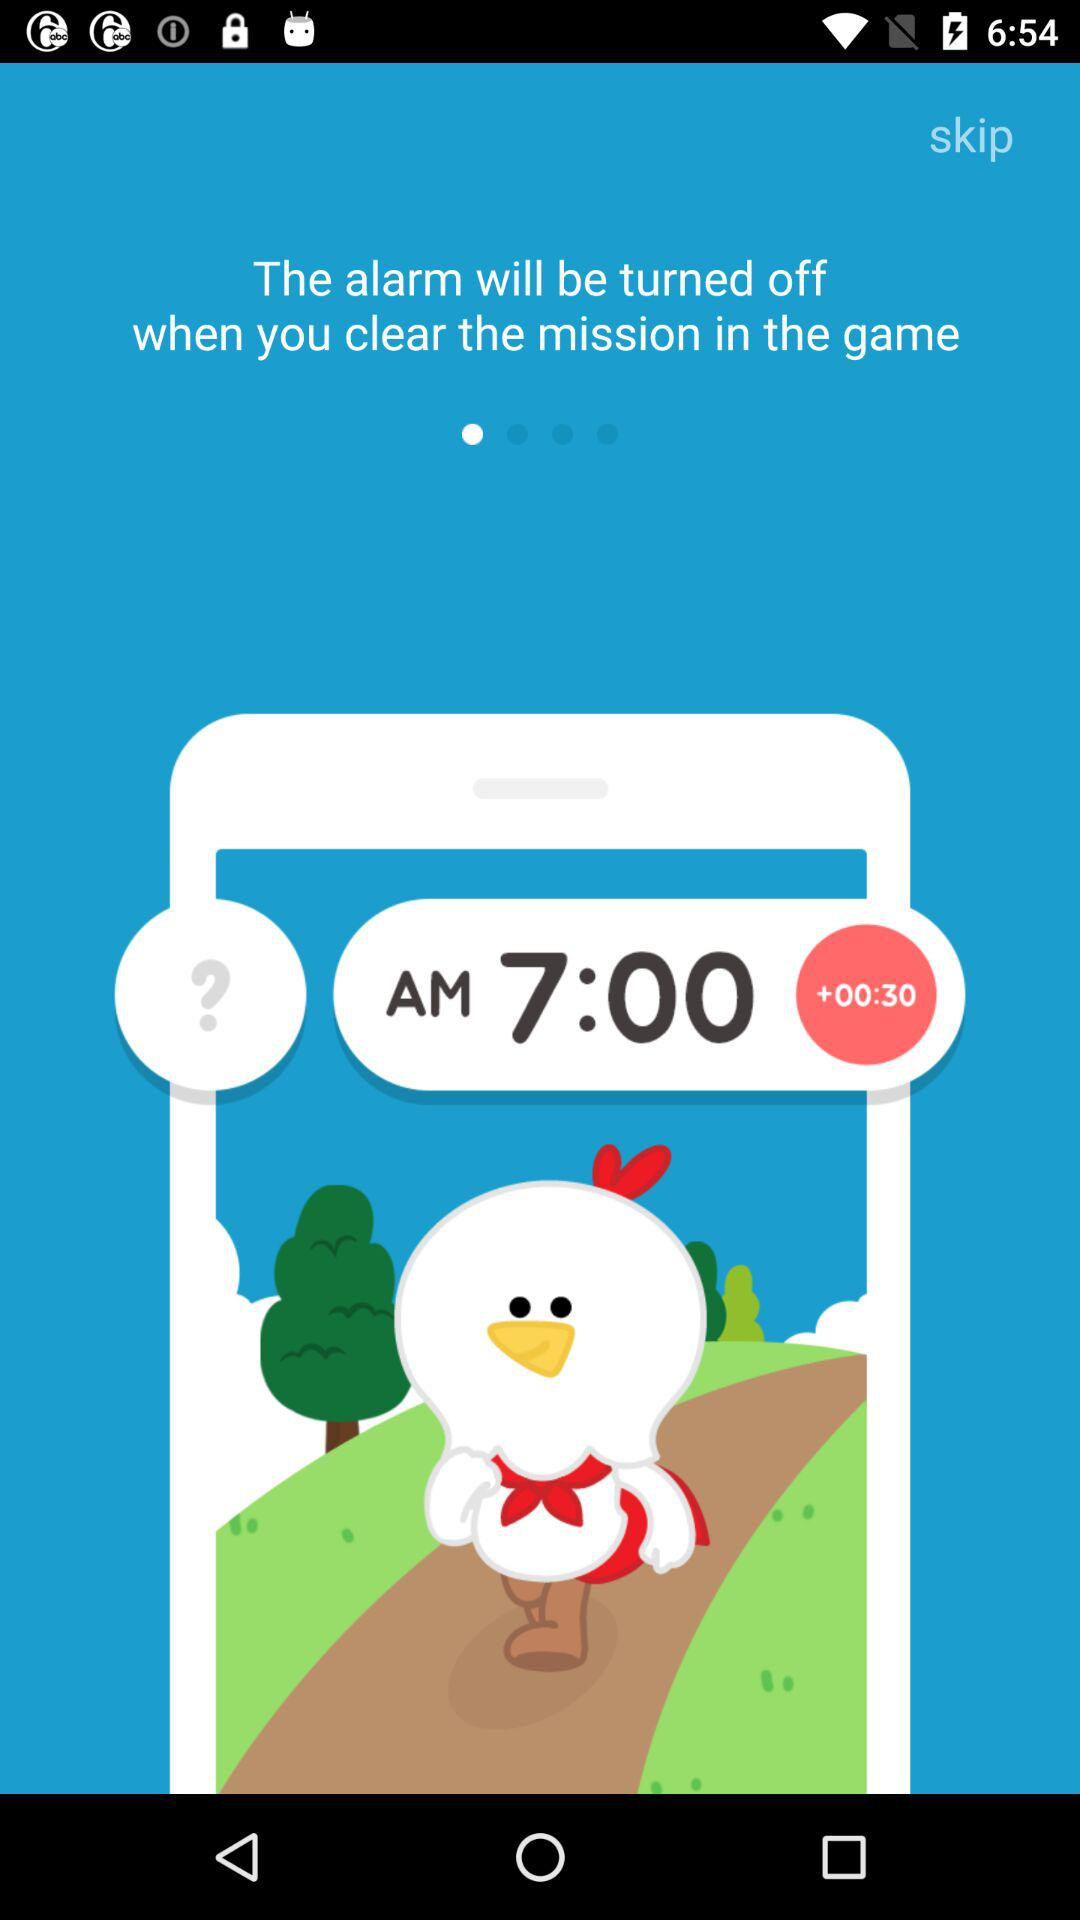What's the time on the screen? The time on the screen is 7:00 a.m. 